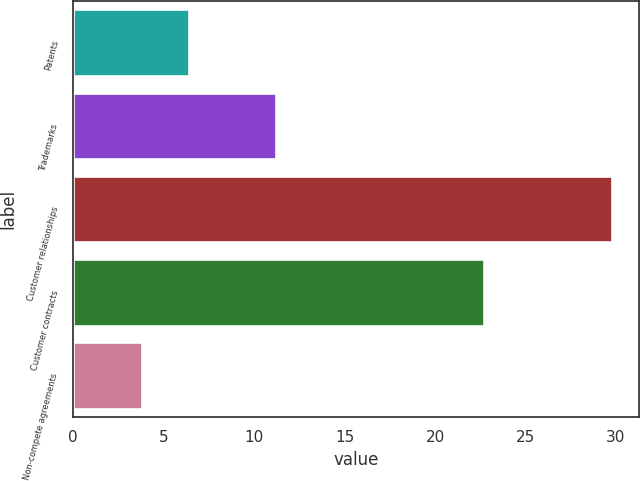<chart> <loc_0><loc_0><loc_500><loc_500><bar_chart><fcel>Patents<fcel>Trademarks<fcel>Customer relationships<fcel>Customer contracts<fcel>Non-compete agreements<nl><fcel>6.4<fcel>11.2<fcel>29.8<fcel>22.7<fcel>3.8<nl></chart> 